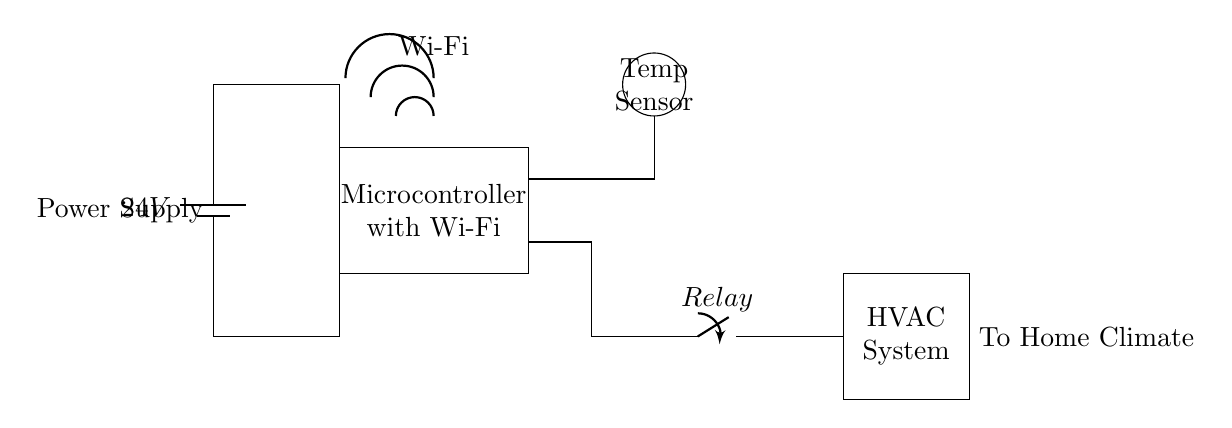What is the main power supply voltage in this circuit? The circuit uses a battery for power, which is indicated as 24 volts. This is a basic observation since there's a clear label next to the battery component showing its voltage rating.
Answer: 24 volts What component controls the HVAC system's operation? The relay is the component responsible for controlling the HVAC system. It is directly connected to the microcontroller, which indicates it can open or close the circuit to the HVAC based on signals from the thermostat.
Answer: Relay How does the microcontroller communicate with the HVAC? The microcontroller sends signals to the relay based on processed data from the temperature sensor, which adjusts the HVAC accordingly. The Wi-Fi connectivity suggests that it allows remote communication as well.
Answer: Through the relay What is the role of the temperature sensor in this circuit? The temperature sensor detects the ambient air temperature and provides this information to the microcontroller. The microcontroller then uses this information to make decisions about activating or deactivating the HVAC system.
Answer: Measure temperature What is the purpose of the Wi-Fi connectivity in this thermostat circuit? The Wi-Fi connectivity allows the thermostat to communicate remotely, enabling users to control and monitor their home climate via a smartphone or computer. This feature highlights the smart functionality of the thermostat.
Answer: Remote control How is power supplied to the microcontroller? The microcontroller receives power from the 24V supply, as shown by the connection from the battery directly to the microcontroller component. This connection diagrammatically illustrates where the power originates.
Answer: From the battery What is the relationship between the temperature sensor and the microcontroller? The temperature sensor sends temperature readings to the microcontroller, which processes this data to make decisions regarding the HVAC system. This interplay is crucial for the climate control function of the thermostat.
Answer: Data input for control 